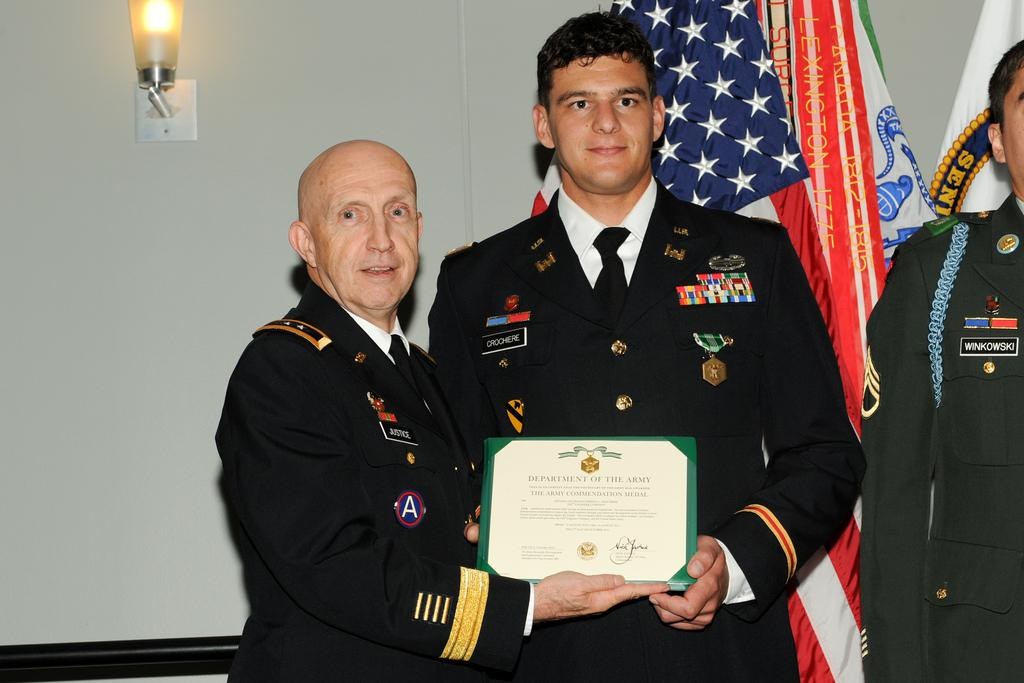How many people are in the image? Two persons are standing in the middle of the image. What are the persons holding in the image? The persons are holding a frame. What can be seen behind the persons? There are flags visible behind the persons. What is in the background of the image? There is a wall in the background. What is on the wall in the image? There is a light on the wall. What type of muscle is being flexed by the ghost in the image? There is no ghost present in the image, and therefore no muscle can be flexed by a ghost. 